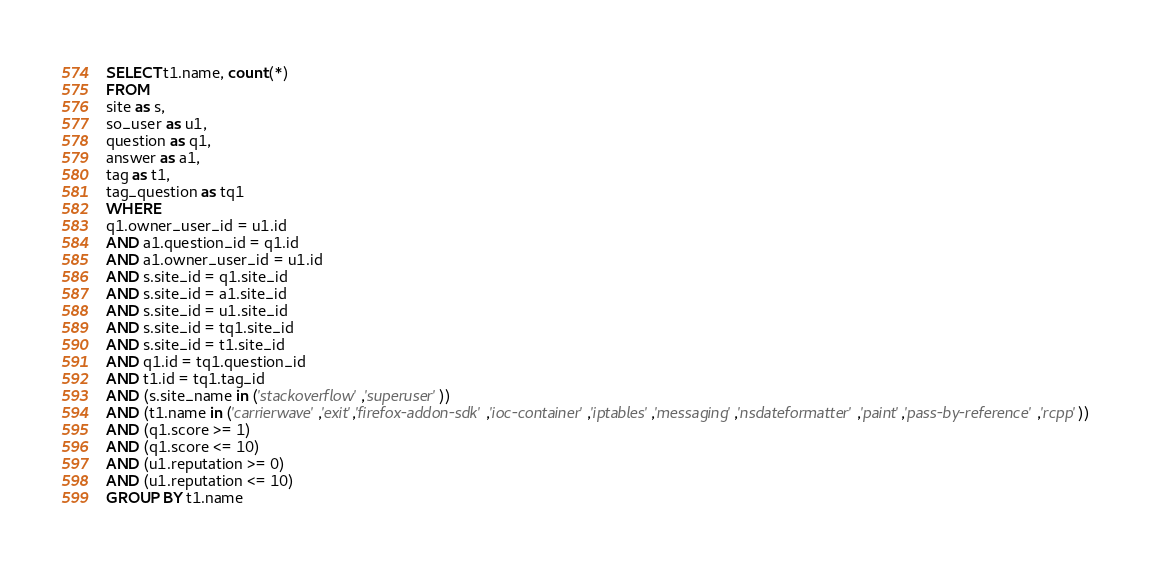<code> <loc_0><loc_0><loc_500><loc_500><_SQL_>SELECT t1.name, count(*)
FROM
site as s,
so_user as u1,
question as q1,
answer as a1,
tag as t1,
tag_question as tq1
WHERE
q1.owner_user_id = u1.id
AND a1.question_id = q1.id
AND a1.owner_user_id = u1.id
AND s.site_id = q1.site_id
AND s.site_id = a1.site_id
AND s.site_id = u1.site_id
AND s.site_id = tq1.site_id
AND s.site_id = t1.site_id
AND q1.id = tq1.question_id
AND t1.id = tq1.tag_id
AND (s.site_name in ('stackoverflow','superuser'))
AND (t1.name in ('carrierwave','exit','firefox-addon-sdk','ioc-container','iptables','messaging','nsdateformatter','paint','pass-by-reference','rcpp'))
AND (q1.score >= 1)
AND (q1.score <= 10)
AND (u1.reputation >= 0)
AND (u1.reputation <= 10)
GROUP BY t1.name</code> 